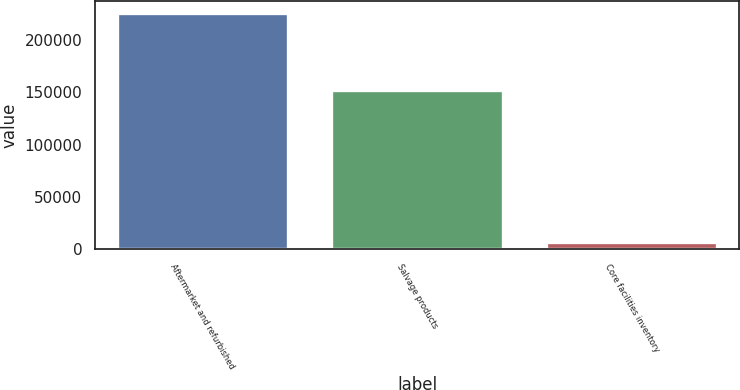Convert chart. <chart><loc_0><loc_0><loc_500><loc_500><bar_chart><fcel>Aftermarket and refurbished<fcel>Salvage products<fcel>Core facilities inventory<nl><fcel>226299<fcel>152438<fcel>6949<nl></chart> 